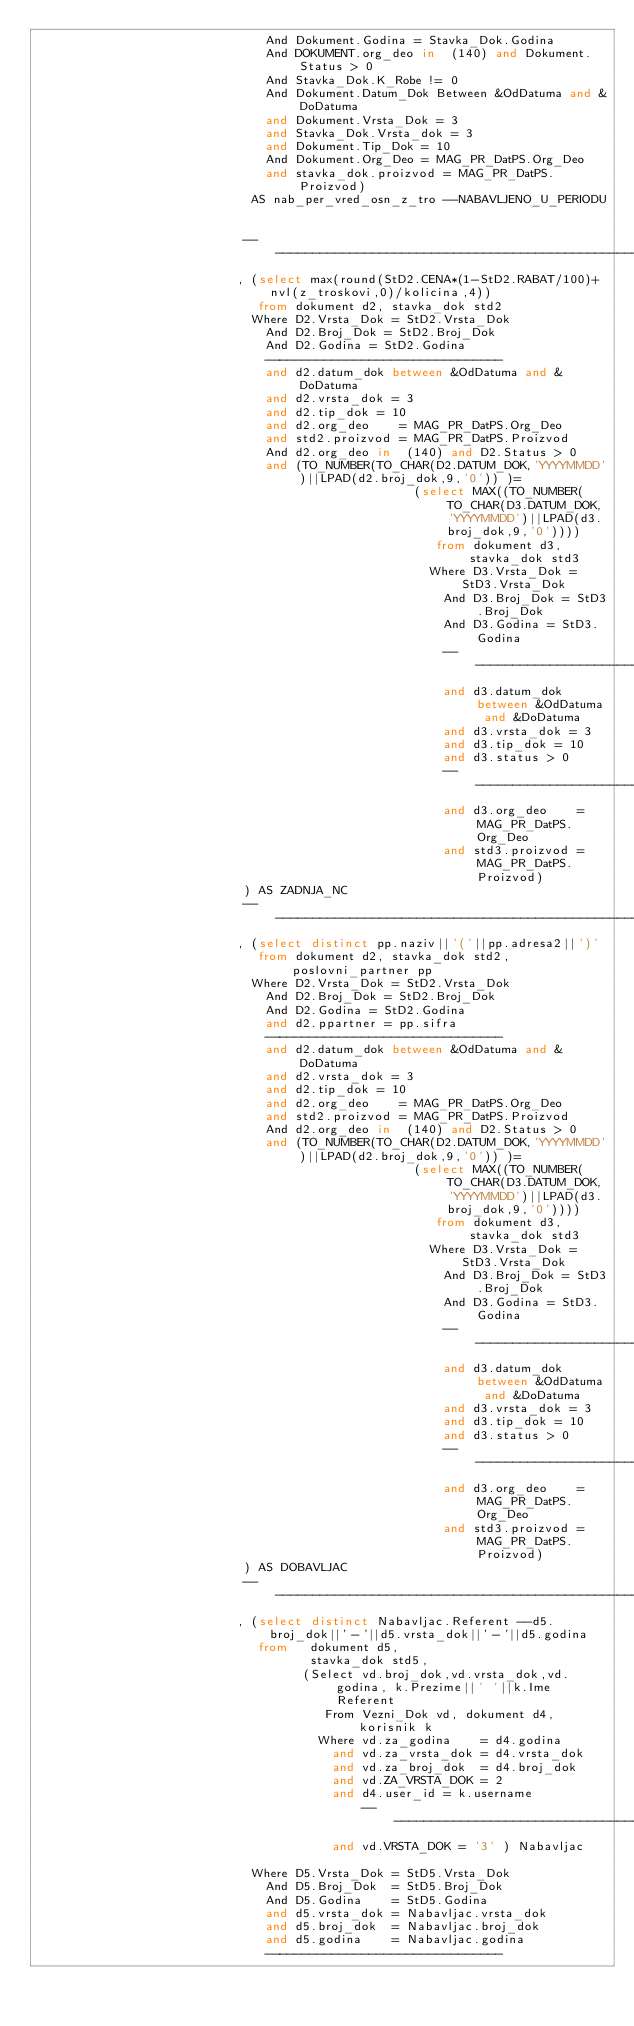<code> <loc_0><loc_0><loc_500><loc_500><_SQL_>                               And Dokument.Godina = Stavka_Dok.Godina
                               And DOKUMENT.org_deo in  (140) and Dokument.Status > 0
                               And Stavka_Dok.K_Robe != 0
                               And Dokument.Datum_Dok Between &OdDatuma and &DoDatuma
                               and Dokument.Vrsta_Dok = 3
                               and Stavka_Dok.Vrsta_dok = 3
                               and Dokument.Tip_Dok = 10
                               And Dokument.Org_Deo = MAG_PR_DatPS.Org_Deo
                               and stavka_dok.proizvod = MAG_PR_DatPS.Proizvod)
                             AS nab_per_vred_osn_z_tro --NABAVLJENO_U_PERIODU


                            ----------------------------------------------------------------------------
                           , (select max(round(StD2.CENA*(1-StD2.RABAT/100)+nvl(z_troskovi,0)/kolicina,4))
                              from dokument d2, stavka_dok std2
                             Where D2.Vrsta_Dok = StD2.Vrsta_Dok
                               And D2.Broj_Dok = StD2.Broj_Dok
                               And D2.Godina = StD2.Godina
                               --------------------------------
                               and d2.datum_dok between &OdDatuma and &DoDatuma
                               and d2.vrsta_dok = 3
                               and d2.tip_dok = 10
                               and d2.org_deo    = MAG_PR_DatPS.Org_Deo
                               and std2.proizvod = MAG_PR_DatPS.Proizvod
                               And d2.org_deo in  (140) and D2.Status > 0
                               and (TO_NUMBER(TO_CHAR(D2.DATUM_DOK,'YYYYMMDD')||LPAD(d2.broj_dok,9,'0')) )=
                                                   (select MAX((TO_NUMBER(TO_CHAR(D3.DATUM_DOK,'YYYYMMDD')||LPAD(d3.broj_dok,9,'0'))))
                                                      from dokument d3, stavka_dok std3
                                                     Where D3.Vrsta_Dok = StD3.Vrsta_Dok
                                                       And D3.Broj_Dok = StD3.Broj_Dok
                                                       And D3.Godina = StD3.Godina
                                                       --------------------------------
                                                       and d3.datum_dok between &OdDatuma and &DoDatuma
                                                       and d3.vrsta_dok = 3
                                                       and d3.tip_dok = 10
                                                       and d3.status > 0
                                                       --------------------------------
                                                       and d3.org_deo    = MAG_PR_DatPS.Org_Deo
                                                       and std3.proizvod = MAG_PR_DatPS.Proizvod)
                            ) AS ZADNJA_NC
                            ----------------------------------------------------------------------------
                           , (select distinct pp.naziv||'('||pp.adresa2||')'
                              from dokument d2, stavka_dok std2, poslovni_partner pp
                             Where D2.Vrsta_Dok = StD2.Vrsta_Dok
                               And D2.Broj_Dok = StD2.Broj_Dok
                               And D2.Godina = StD2.Godina
                               and d2.ppartner = pp.sifra
                               --------------------------------
                               and d2.datum_dok between &OdDatuma and &DoDatuma
                               and d2.vrsta_dok = 3
                               and d2.tip_dok = 10
                               and d2.org_deo    = MAG_PR_DatPS.Org_Deo
                               and std2.proizvod = MAG_PR_DatPS.Proizvod
                               And d2.org_deo in  (140) and D2.Status > 0
                               and (TO_NUMBER(TO_CHAR(D2.DATUM_DOK,'YYYYMMDD')||LPAD(d2.broj_dok,9,'0')) )=
                                                   (select MAX((TO_NUMBER(TO_CHAR(D3.DATUM_DOK,'YYYYMMDD')||LPAD(d3.broj_dok,9,'0'))))
                                                      from dokument d3, stavka_dok std3
                                                     Where D3.Vrsta_Dok = StD3.Vrsta_Dok
                                                       And D3.Broj_Dok = StD3.Broj_Dok
                                                       And D3.Godina = StD3.Godina
                                                       --------------------------------
                                                       and d3.datum_dok between &OdDatuma and &DoDatuma
                                                       and d3.vrsta_dok = 3
                                                       and d3.tip_dok = 10
                                                       and d3.status > 0
                                                       --------------------------------
                                                       and d3.org_deo    = MAG_PR_DatPS.Org_Deo
                                                       and std3.proizvod = MAG_PR_DatPS.Proizvod)
                            ) AS DOBAVLJAC
                            ----------------------------------------------------------------------------
                           , (select distinct Nabavljac.Referent --d5.broj_dok||'-'||d5.vrsta_dok||'-'||d5.godina
                              from   dokument d5,
                                     stavka_dok std5,
                                    (Select vd.broj_dok,vd.vrsta_dok,vd.godina, k.Prezime||' '||k.Ime Referent
                                       From Vezni_Dok vd, dokument d4, korisnik k
                                      Where vd.za_godina    = d4.godina
                                        and vd.za_vrsta_dok = d4.vrsta_dok
                                        and vd.za_broj_dok  = d4.broj_dok
                                        and vd.ZA_VRSTA_DOK = 2
                                        and d4.user_id = k.username
                                            ------------------------------------
                                        and vd.VRSTA_DOK = '3' ) Nabavljac

                             Where D5.Vrsta_Dok = StD5.Vrsta_Dok
                               And D5.Broj_Dok  = StD5.Broj_Dok
                               And D5.Godina    = StD5.Godina
                               and d5.vrsta_dok = Nabavljac.vrsta_dok
                               and d5.broj_dok  = Nabavljac.broj_dok
                               and d5.godina    = Nabavljac.godina
                               --------------------------------</code> 